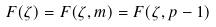Convert formula to latex. <formula><loc_0><loc_0><loc_500><loc_500>F ( \zeta ) = F ( \zeta , m ) = F ( \zeta , p - 1 )</formula> 